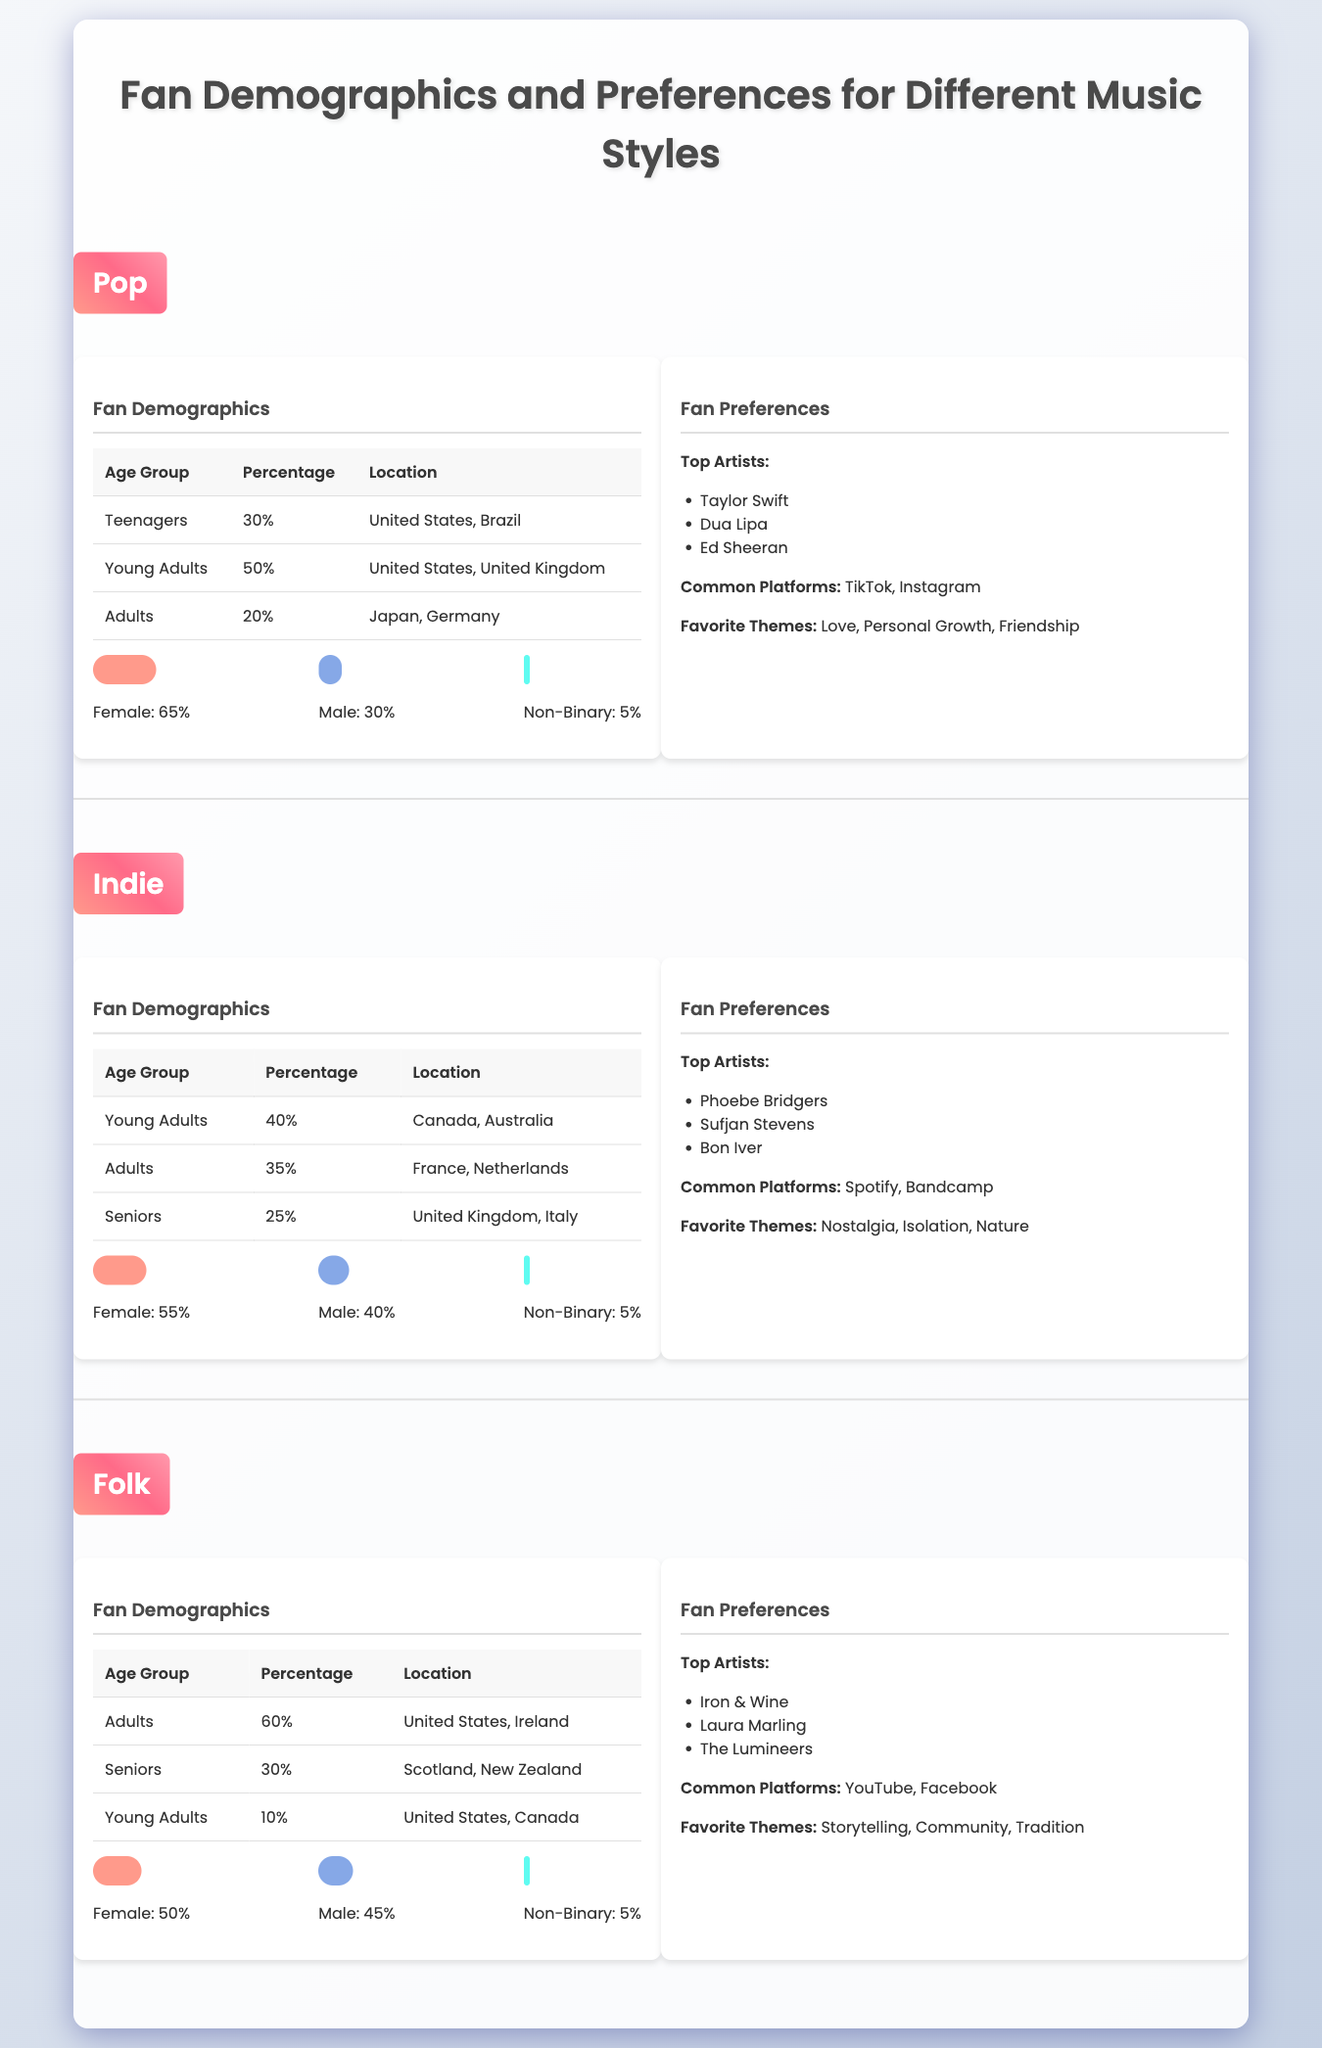What percentage of Pop music fans are young adults? According to the Pop section of the table, young adults make up 50% of the fan demographics. This is based on the age group statistics provided.
Answer: 50% Which music style has the highest percentage of adults among its fans? Reviewing the adult percentages for each music style, Pop has 20%, Indie has 35%, and Folk has 60%. Folk has the highest percentage of adults among its fans.
Answer: Folk Is the majority of Pop music fans female? The Gender Distribution for Pop shows that females represent 65% of the fan base. Since this is greater than 50%, the fact is true.
Answer: Yes What are the common platforms for Indie music fans? The Indie section lists Spotify and Bandcamp as the common platforms that fans prefer. This information is explicitly stated in the preferences section for Indie music.
Answer: Spotify, Bandcamp What is the total percentage of Young Adults across all music styles? From the demographic data: Pop has 50%, Indie has 40%, and Folk has 10% for young adults. Adding these together: 50 + 40 + 10 = 100.
Answer: 100% Which music style has the highest percentage of seniors? Looking at the senior demographics: Pop has 20%, Indie has 25%, and Folk has 30%. Folk has the highest percentage of seniors among the music styles.
Answer: Folk How does the gender distribution of Folk music compare to Indie music? For Folk, the gender distribution is 50% female, 45% male, and 5% non-binary. For Indie, it is 55% female, 40% male, and 5% non-binary. The Folk distribution has a lower female percentage and slightly higher male percentage than Indie.
Answer: Folk has lower female and higher male percentages than Indie What is the favorite theme for Pop music fans? The Pop fan preferences document love, personal growth, and friendship as favorite themes. This is directly listed in the fan preferences section of Pop.
Answer: Love, Personal Growth, Friendship 